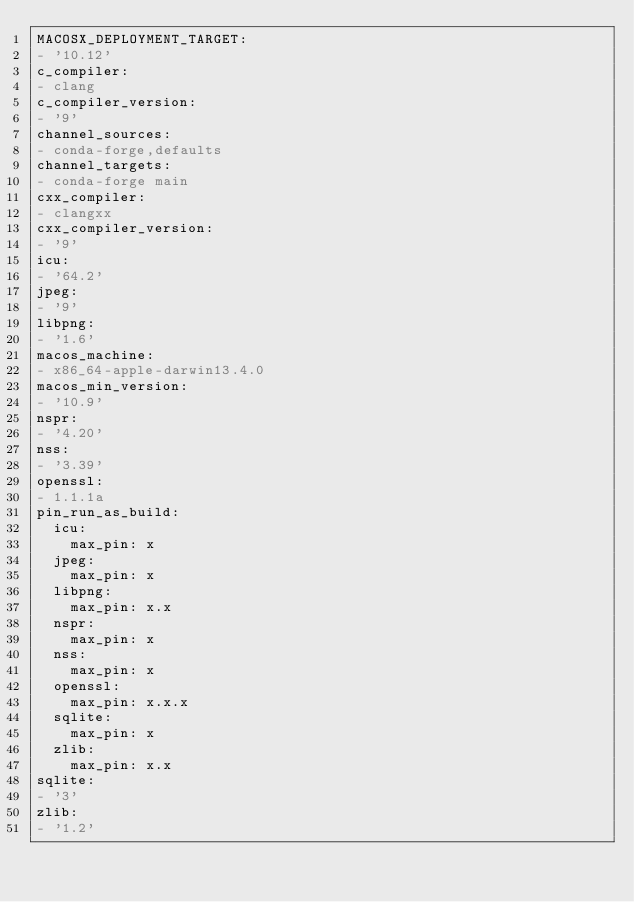<code> <loc_0><loc_0><loc_500><loc_500><_YAML_>MACOSX_DEPLOYMENT_TARGET:
- '10.12'
c_compiler:
- clang
c_compiler_version:
- '9'
channel_sources:
- conda-forge,defaults
channel_targets:
- conda-forge main
cxx_compiler:
- clangxx
cxx_compiler_version:
- '9'
icu:
- '64.2'
jpeg:
- '9'
libpng:
- '1.6'
macos_machine:
- x86_64-apple-darwin13.4.0
macos_min_version:
- '10.9'
nspr:
- '4.20'
nss:
- '3.39'
openssl:
- 1.1.1a
pin_run_as_build:
  icu:
    max_pin: x
  jpeg:
    max_pin: x
  libpng:
    max_pin: x.x
  nspr:
    max_pin: x
  nss:
    max_pin: x
  openssl:
    max_pin: x.x.x
  sqlite:
    max_pin: x
  zlib:
    max_pin: x.x
sqlite:
- '3'
zlib:
- '1.2'
</code> 